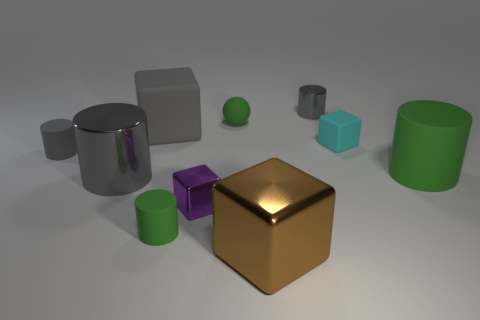How many gray cylinders must be subtracted to get 1 gray cylinders? 2 Subtract all green balls. How many gray cylinders are left? 3 Subtract all large green cylinders. How many cylinders are left? 4 Subtract 1 cylinders. How many cylinders are left? 4 Subtract all cyan cylinders. Subtract all purple cubes. How many cylinders are left? 5 Subtract all spheres. How many objects are left? 9 Add 2 tiny green objects. How many tiny green objects exist? 4 Subtract 0 blue cubes. How many objects are left? 10 Subtract all large purple metal cubes. Subtract all brown metallic objects. How many objects are left? 9 Add 5 tiny green cylinders. How many tiny green cylinders are left? 6 